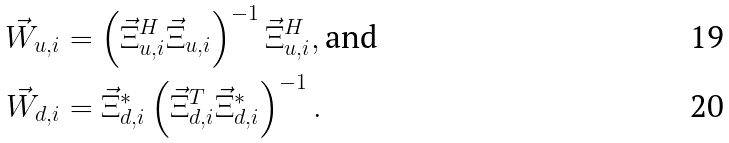<formula> <loc_0><loc_0><loc_500><loc_500>\vec { W } _ { u , i } & = \left ( \vec { \Xi } _ { u , i } ^ { H } \vec { \Xi } _ { u , i } \right ) ^ { - 1 } \vec { \Xi } _ { u , i } ^ { H } , \text {and} \\ \vec { W } _ { d , i } & = \vec { \Xi } _ { d , i } ^ { * } \left ( \vec { \Xi } _ { d , i } ^ { T } \vec { \Xi } _ { d , i } ^ { * } \right ) ^ { - 1 } .</formula> 